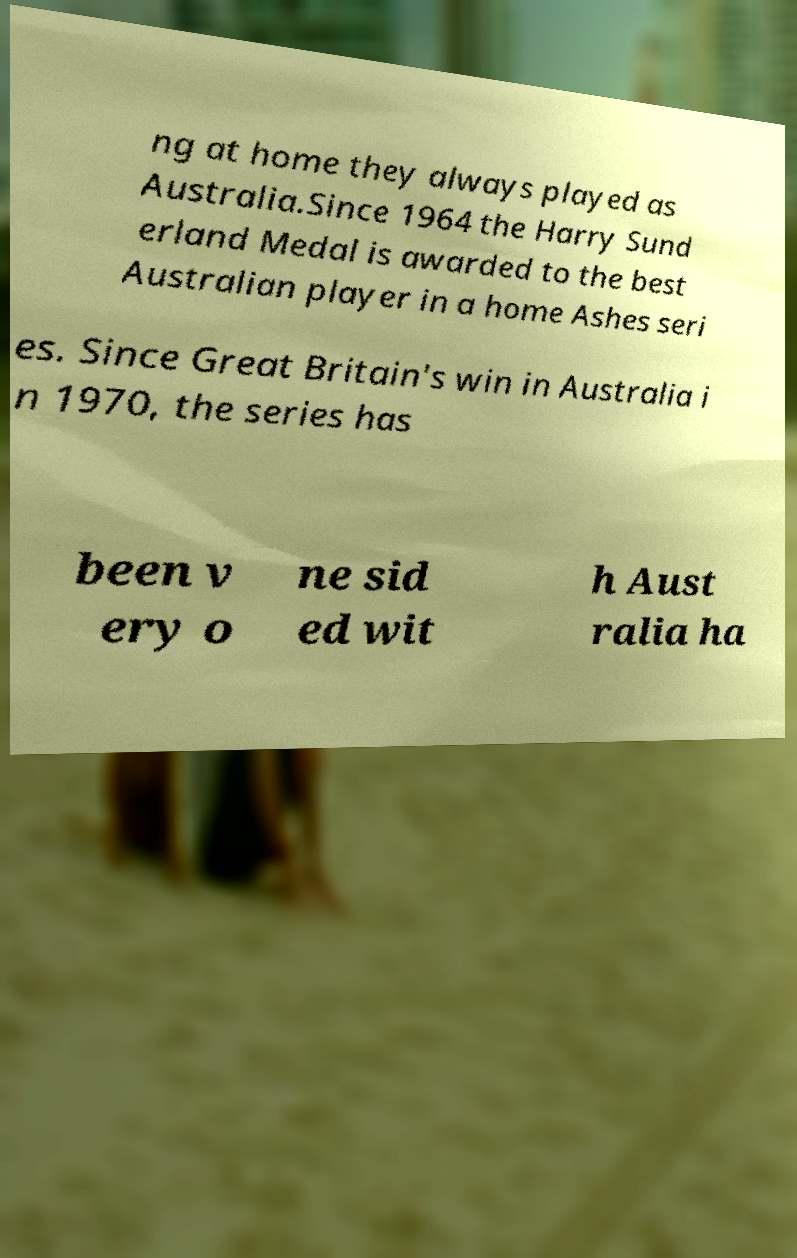There's text embedded in this image that I need extracted. Can you transcribe it verbatim? ng at home they always played as Australia.Since 1964 the Harry Sund erland Medal is awarded to the best Australian player in a home Ashes seri es. Since Great Britain's win in Australia i n 1970, the series has been v ery o ne sid ed wit h Aust ralia ha 